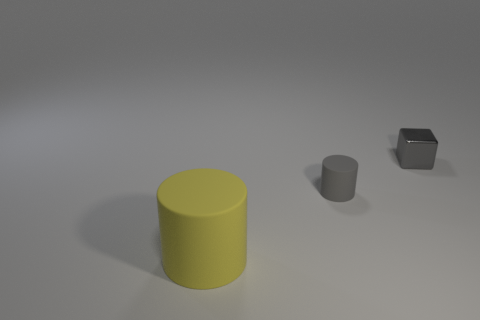Add 3 tiny red metallic cubes. How many objects exist? 6 Subtract all blocks. How many objects are left? 2 Add 3 small shiny objects. How many small shiny objects exist? 4 Subtract 0 red blocks. How many objects are left? 3 Subtract all small matte objects. Subtract all yellow matte objects. How many objects are left? 1 Add 2 tiny gray blocks. How many tiny gray blocks are left? 3 